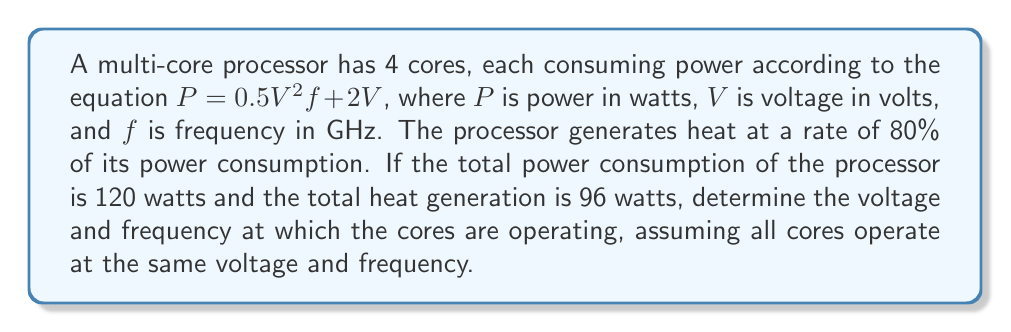Give your solution to this math problem. Let's approach this step-by-step:

1) First, we know that all 4 cores are identical and operating at the same voltage and frequency. So we can set up our first equation based on the total power consumption:

   $$4(0.5V^2f + 2V) = 120$$

2) We're told that heat generation is 80% of power consumption. This gives us our second equation:

   $$0.8 * 120 = 96$$

   This confirms the given heat generation value.

3) Let's simplify our first equation:

   $$2V^2f + 8V = 120$$

4) We can rearrange this to express $f$ in terms of $V$:

   $$f = \frac{120 - 8V}{2V^2}$$

5) Now, we can use a computational approach. We know that $V$ must be positive and less than 15 (as 4 * 2 * 15 = 120, the total power). We can iterate through possible values of $V$ with small increments:

   For $V = 1.0, 1.1, 1.2, ...$
   Calculate $f$ using the equation from step 4
   Check if $f$ is a reasonable value (between 0 and 10 GHz)

6) Using this method (or solving numerically), we find that when $V \approx 1.67$ volts, $f \approx 3.33$ GHz.

7) We can verify:
   $$P = 4(0.5 * 1.67^2 * 3.33 + 2 * 1.67) \approx 120$$ watts

   Heat generation = $0.8 * 120 = 96$ watts
Answer: Voltage: $V \approx 1.67$ volts
Frequency: $f \approx 3.33$ GHz 